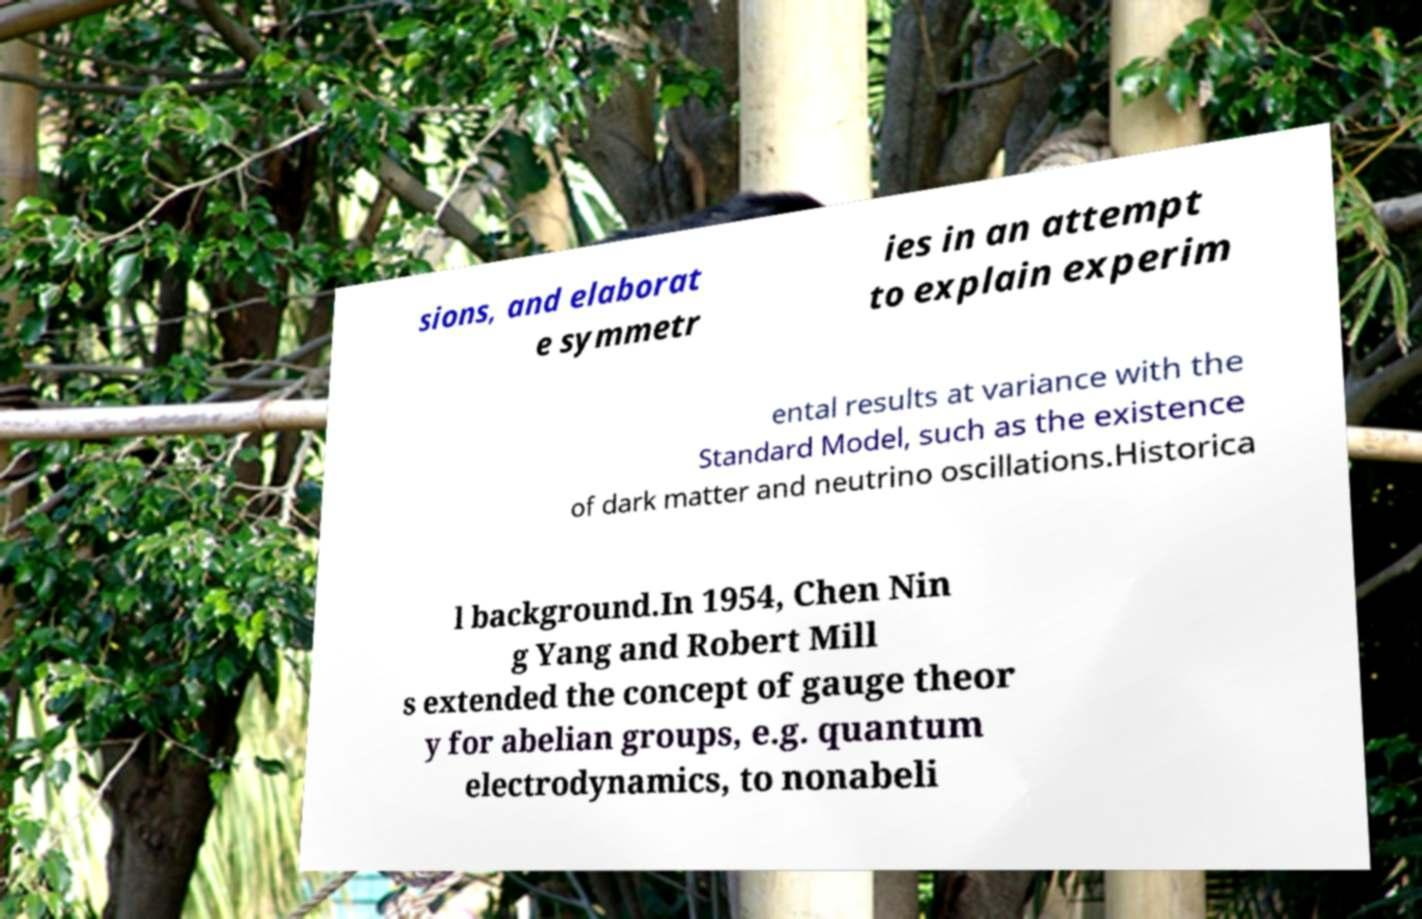Can you accurately transcribe the text from the provided image for me? sions, and elaborat e symmetr ies in an attempt to explain experim ental results at variance with the Standard Model, such as the existence of dark matter and neutrino oscillations.Historica l background.In 1954, Chen Nin g Yang and Robert Mill s extended the concept of gauge theor y for abelian groups, e.g. quantum electrodynamics, to nonabeli 